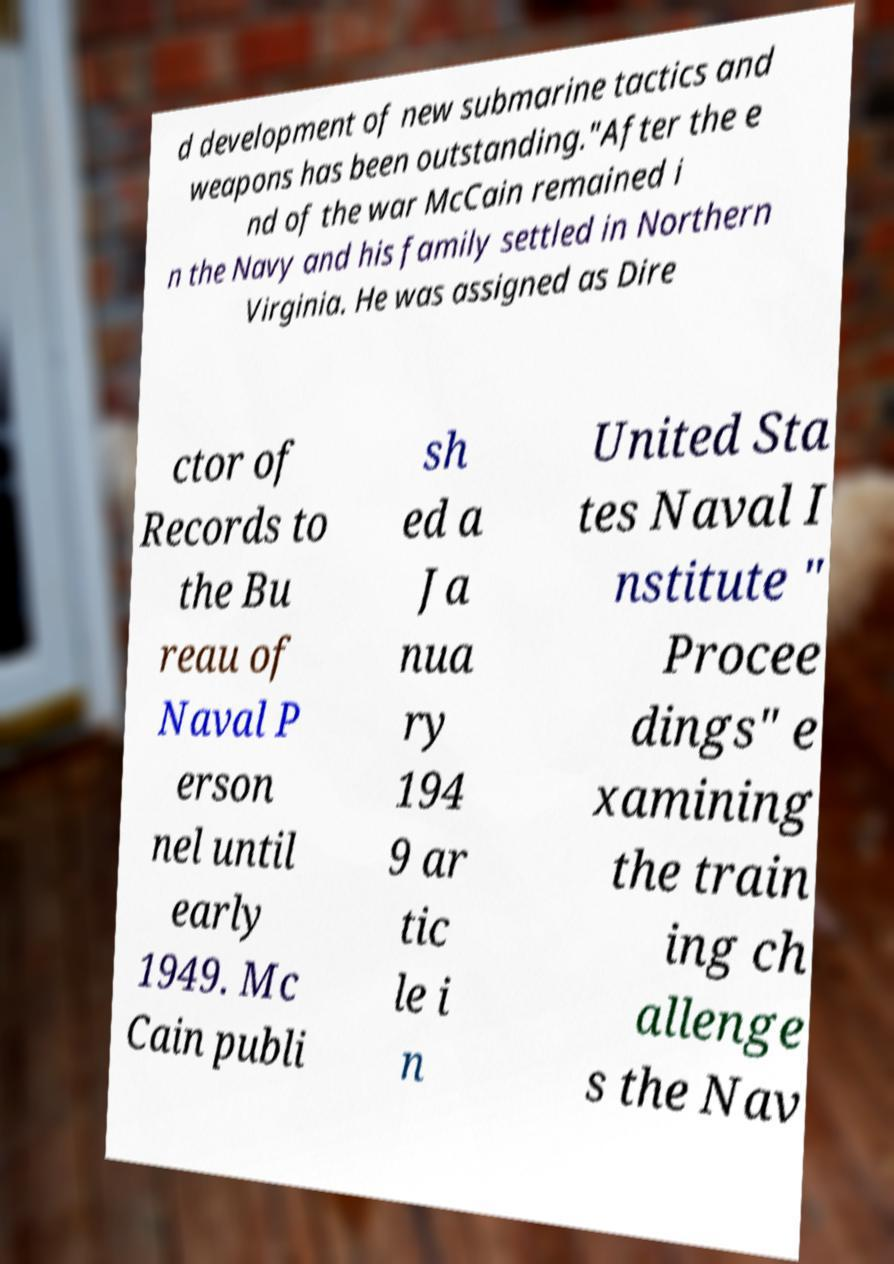Could you assist in decoding the text presented in this image and type it out clearly? d development of new submarine tactics and weapons has been outstanding."After the e nd of the war McCain remained i n the Navy and his family settled in Northern Virginia. He was assigned as Dire ctor of Records to the Bu reau of Naval P erson nel until early 1949. Mc Cain publi sh ed a Ja nua ry 194 9 ar tic le i n United Sta tes Naval I nstitute " Procee dings" e xamining the train ing ch allenge s the Nav 